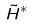<formula> <loc_0><loc_0><loc_500><loc_500>\tilde { H } ^ { * }</formula> 